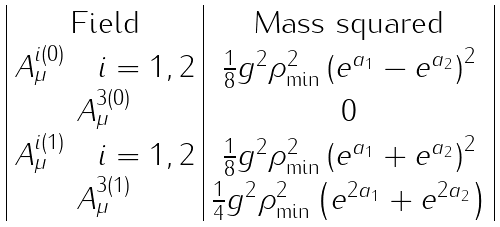<formula> <loc_0><loc_0><loc_500><loc_500>\begin{array} { | c | c | } \text {Field} & \text {Mass squared} \\ A ^ { i ( 0 ) } _ { \mu } \quad i = 1 , 2 & \frac { 1 } { 8 } g ^ { 2 } \rho ^ { 2 } _ { \min } \left ( e ^ { a _ { 1 } } - e ^ { a _ { 2 } } \right ) ^ { 2 } \\ A ^ { 3 ( 0 ) } _ { \mu } & 0 \\ A ^ { i ( 1 ) } _ { \mu } \quad i = 1 , 2 & \frac { 1 } { 8 } g ^ { 2 } \rho ^ { 2 } _ { \min } \left ( e ^ { a _ { 1 } } + e ^ { a _ { 2 } } \right ) ^ { 2 } \\ A ^ { 3 ( 1 ) } _ { \mu } & \frac { 1 } { 4 } g ^ { 2 } \rho ^ { 2 } _ { \min } \left ( e ^ { 2 a _ { 1 } } + e ^ { 2 a _ { 2 } } \right ) \\ \end{array}</formula> 